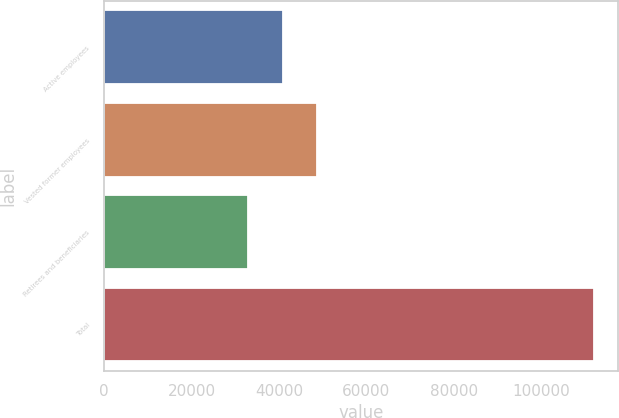Convert chart. <chart><loc_0><loc_0><loc_500><loc_500><bar_chart><fcel>Active employees<fcel>Vested former employees<fcel>Retirees and beneficiaries<fcel>Total<nl><fcel>40900<fcel>48800<fcel>33000<fcel>112000<nl></chart> 